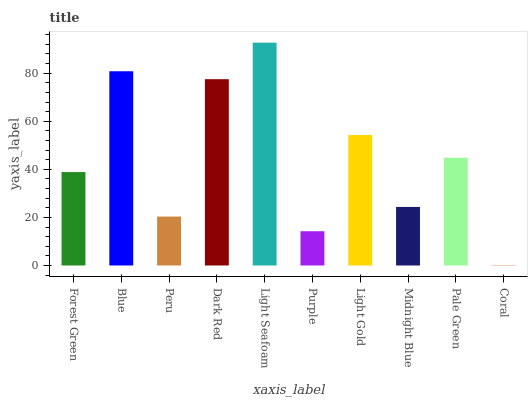Is Blue the minimum?
Answer yes or no. No. Is Blue the maximum?
Answer yes or no. No. Is Blue greater than Forest Green?
Answer yes or no. Yes. Is Forest Green less than Blue?
Answer yes or no. Yes. Is Forest Green greater than Blue?
Answer yes or no. No. Is Blue less than Forest Green?
Answer yes or no. No. Is Pale Green the high median?
Answer yes or no. Yes. Is Forest Green the low median?
Answer yes or no. Yes. Is Light Gold the high median?
Answer yes or no. No. Is Dark Red the low median?
Answer yes or no. No. 